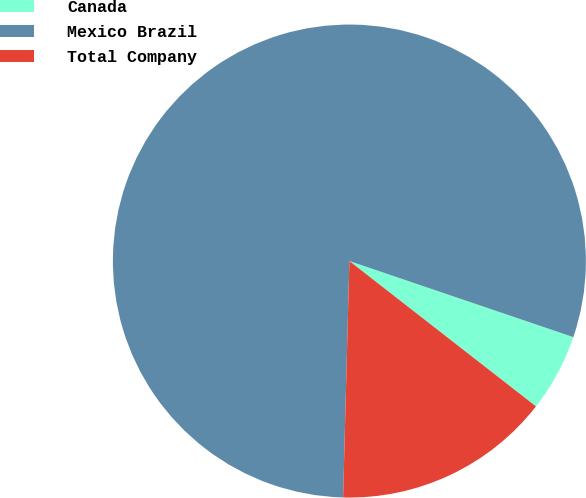Convert chart to OTSL. <chart><loc_0><loc_0><loc_500><loc_500><pie_chart><fcel>Canada<fcel>Mexico Brazil<fcel>Total Company<nl><fcel>5.32%<fcel>79.79%<fcel>14.89%<nl></chart> 